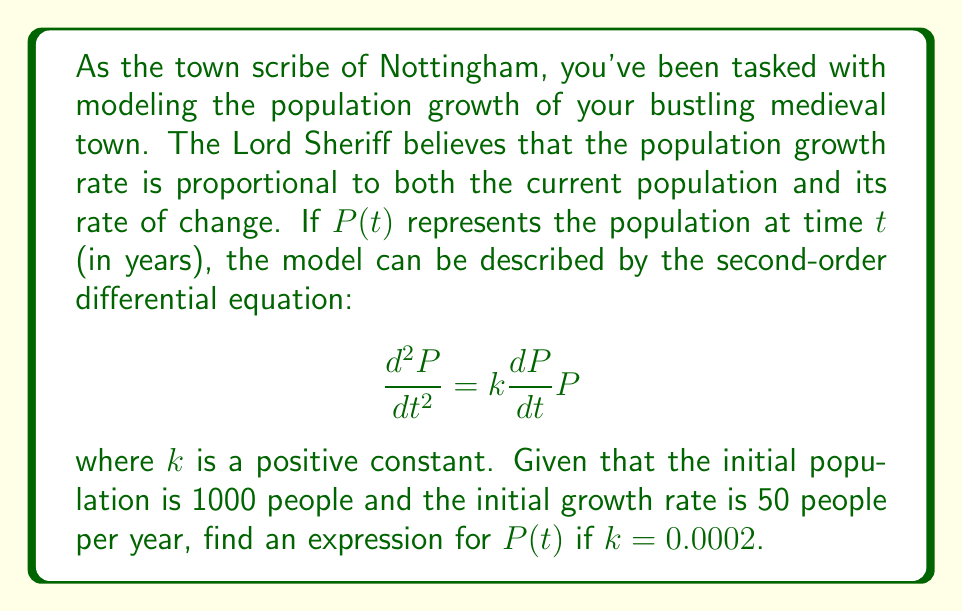Can you solve this math problem? Let's solve this step-by-step:

1) We have a second-order differential equation:
   $$\frac{d^2P}{dt^2} = k\frac{dP}{dt}P$$

2) Let $y = \frac{dP}{dt}$. Then $\frac{d^2P}{dt^2} = \frac{dy}{dt}$.

3) Substituting these into our equation:
   $$\frac{dy}{dt} = kyP$$

4) This is now a separable first-order equation. We can separate variables:
   $$\frac{dy}{y} = kPdt$$

5) Integrating both sides:
   $$\ln|y| = \frac{k}{2}P^2 + C$$

6) Exponentiating both sides:
   $$y = Ae^{\frac{k}{2}P^2}$$
   where $A = \pm e^C$.

7) Substituting back $y = \frac{dP}{dt}$:
   $$\frac{dP}{dt} = Ae^{\frac{k}{2}P^2}$$

8) This is again separable. Separating variables:
   $$\frac{dP}{e^{\frac{k}{2}P^2}} = Adt$$

9) Integrating both sides:
   $$\int\frac{dP}{e^{\frac{k}{2}P^2}} = At + B$$

10) The left side integrates to:
    $$\sqrt{\frac{\pi}{2k}}\text{erf}(\sqrt{\frac{k}{2}}P) = At + B$$

11) Solving for $P$:
    $$P(t) = \sqrt{\frac{2}{k}}\text{erf}^{-1}(\sqrt{\frac{k}{2\pi}}(At + B))$$

12) Now we use the initial conditions:
    $P(0) = 1000$ and $\frac{dP}{dt}(0) = 50$

13) From $P(0) = 1000$:
    $$1000 = \sqrt{\frac{2}{k}}\text{erf}^{-1}(\sqrt{\frac{k}{2\pi}}B)$$

14) From $\frac{dP}{dt}(0) = 50$:
    $$50 = Ae^{\frac{k}{2}(1000)^2}$$

15) Solving these equations with $k = 0.0002$:
    $A \approx 2.7035$ and $B \approx 2506.6$

Therefore, the final solution is:
$$P(t) = \sqrt{10000}\text{erf}^{-1}(0.005623(2.7035t + 2506.6))$$
Answer: $P(t) = 100\text{erf}^{-1}(0.005623(2.7035t + 2506.6))$ 